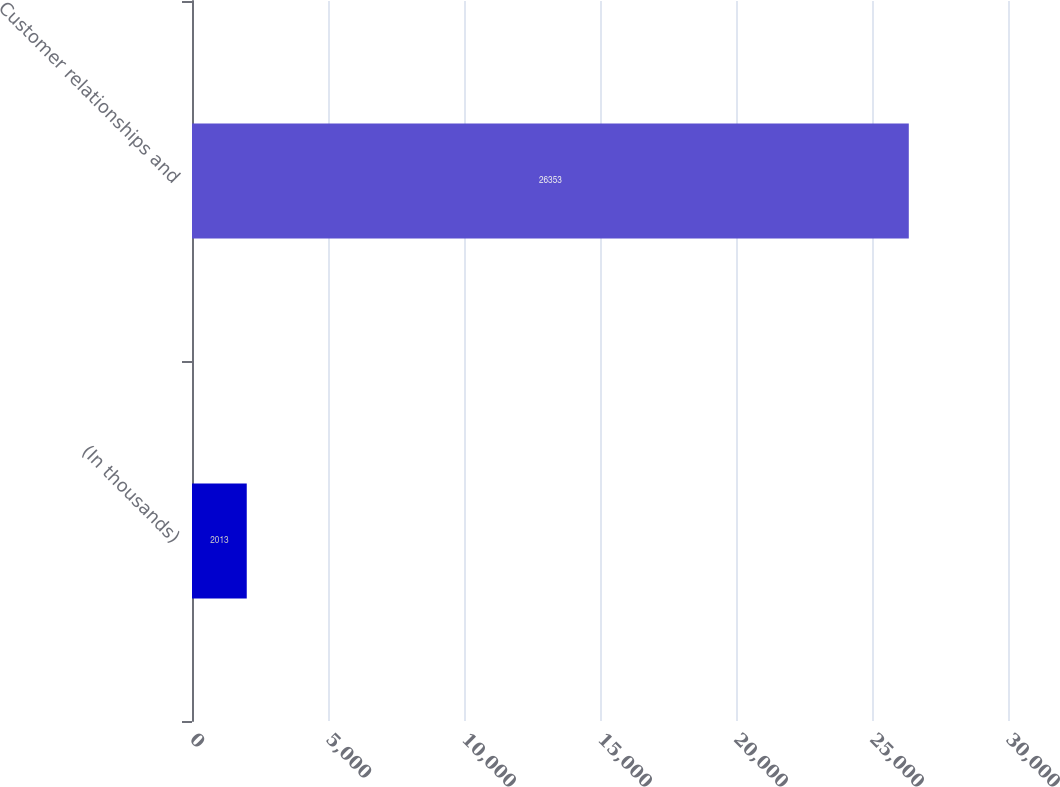Convert chart to OTSL. <chart><loc_0><loc_0><loc_500><loc_500><bar_chart><fcel>(In thousands)<fcel>Customer relationships and<nl><fcel>2013<fcel>26353<nl></chart> 